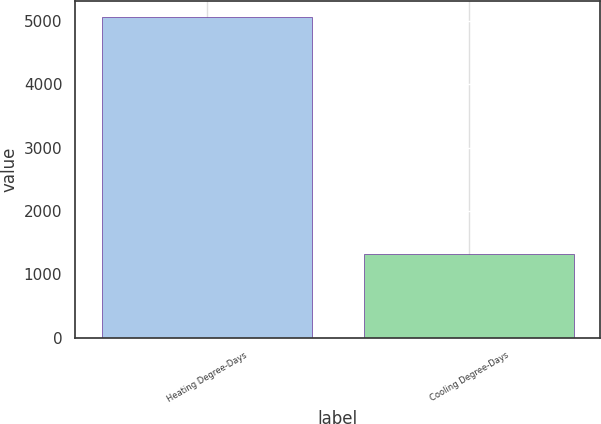<chart> <loc_0><loc_0><loc_500><loc_500><bar_chart><fcel>Heating Degree-Days<fcel>Cooling Degree-Days<nl><fcel>5065<fcel>1324<nl></chart> 